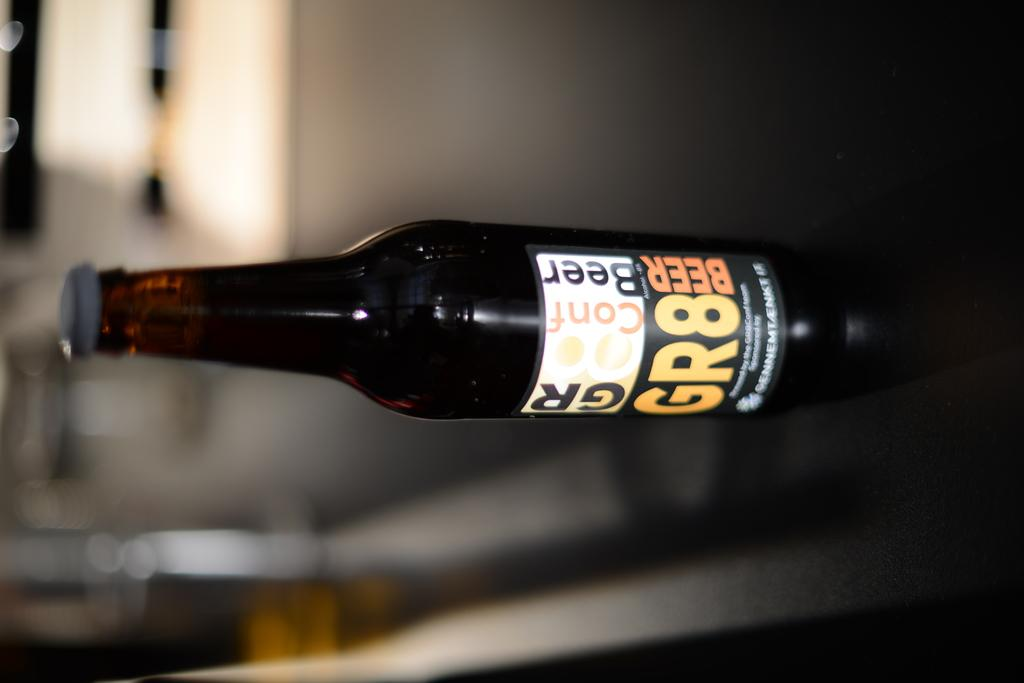<image>
Share a concise interpretation of the image provided. A bottle of beer that has a label that says GR8 on it. 